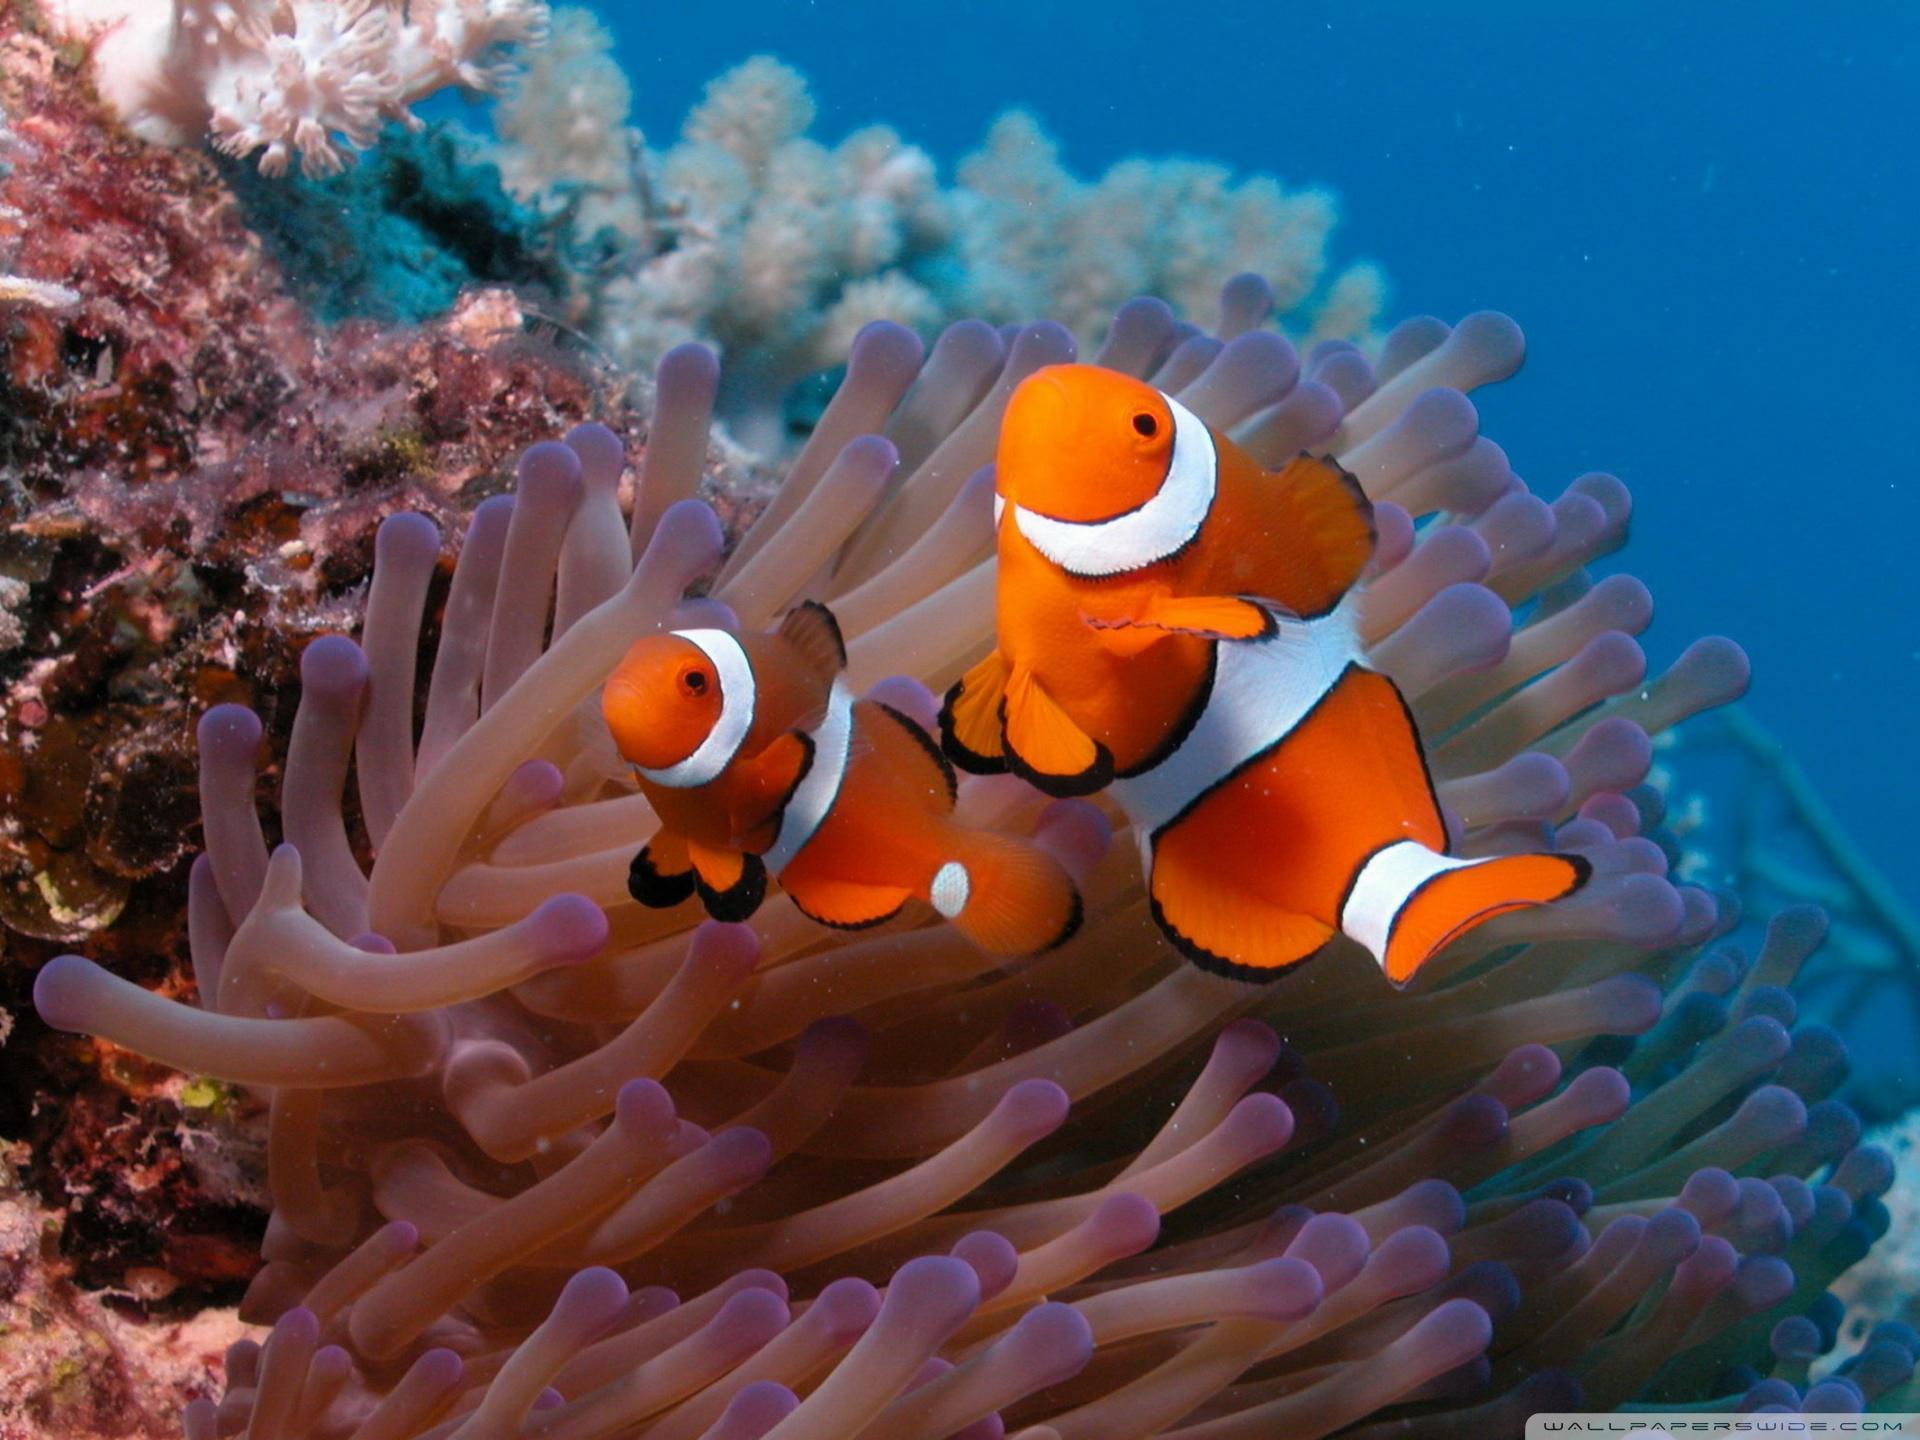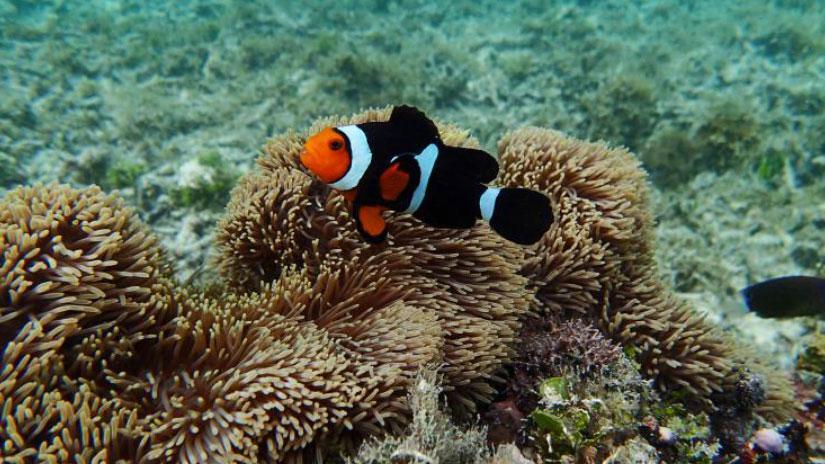The first image is the image on the left, the second image is the image on the right. Evaluate the accuracy of this statement regarding the images: "An image shows exactly one clownfish swimming near neutral-colored anemone tendrils.". Is it true? Answer yes or no. Yes. The first image is the image on the left, the second image is the image on the right. Examine the images to the left and right. Is the description "The right image contains exactly one clown fish." accurate? Answer yes or no. Yes. 